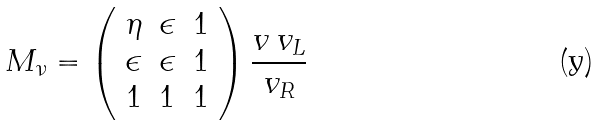Convert formula to latex. <formula><loc_0><loc_0><loc_500><loc_500>M _ { \nu } = \left ( \begin{array} { c c c } \eta & \epsilon & 1 \\ \epsilon & \epsilon & 1 \\ 1 & 1 & 1 \end{array} \right ) \frac { v \, v _ { L } } { v _ { R } }</formula> 